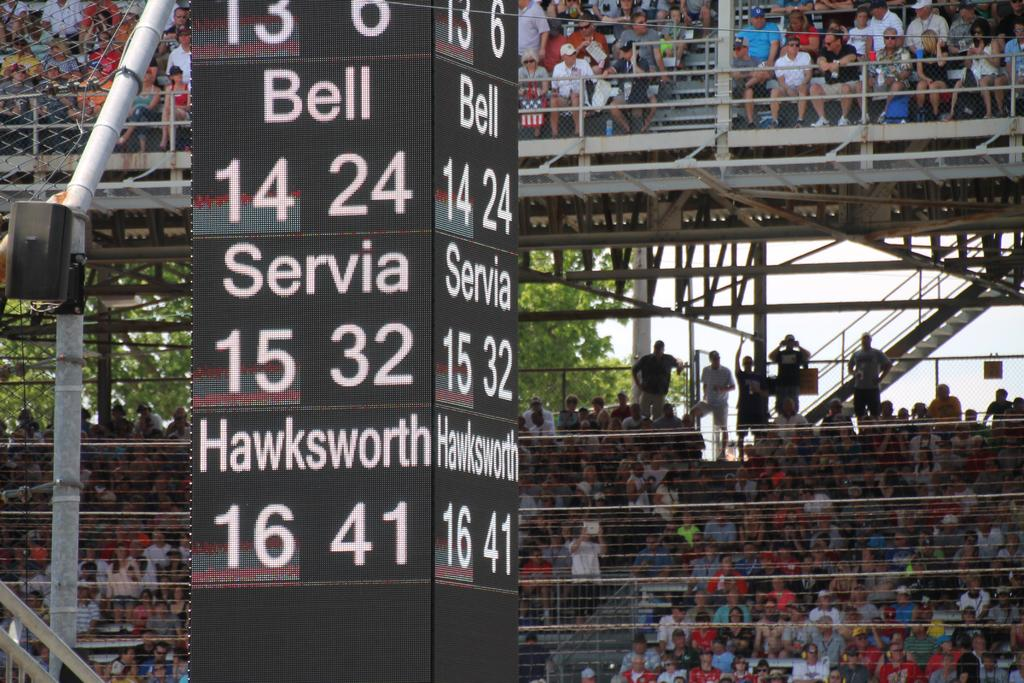<image>
Share a concise interpretation of the image provided. Stadium score board listing Bell 14 24, Servia 15 32,  Hawkworth 16 41 in digital on all sides. 